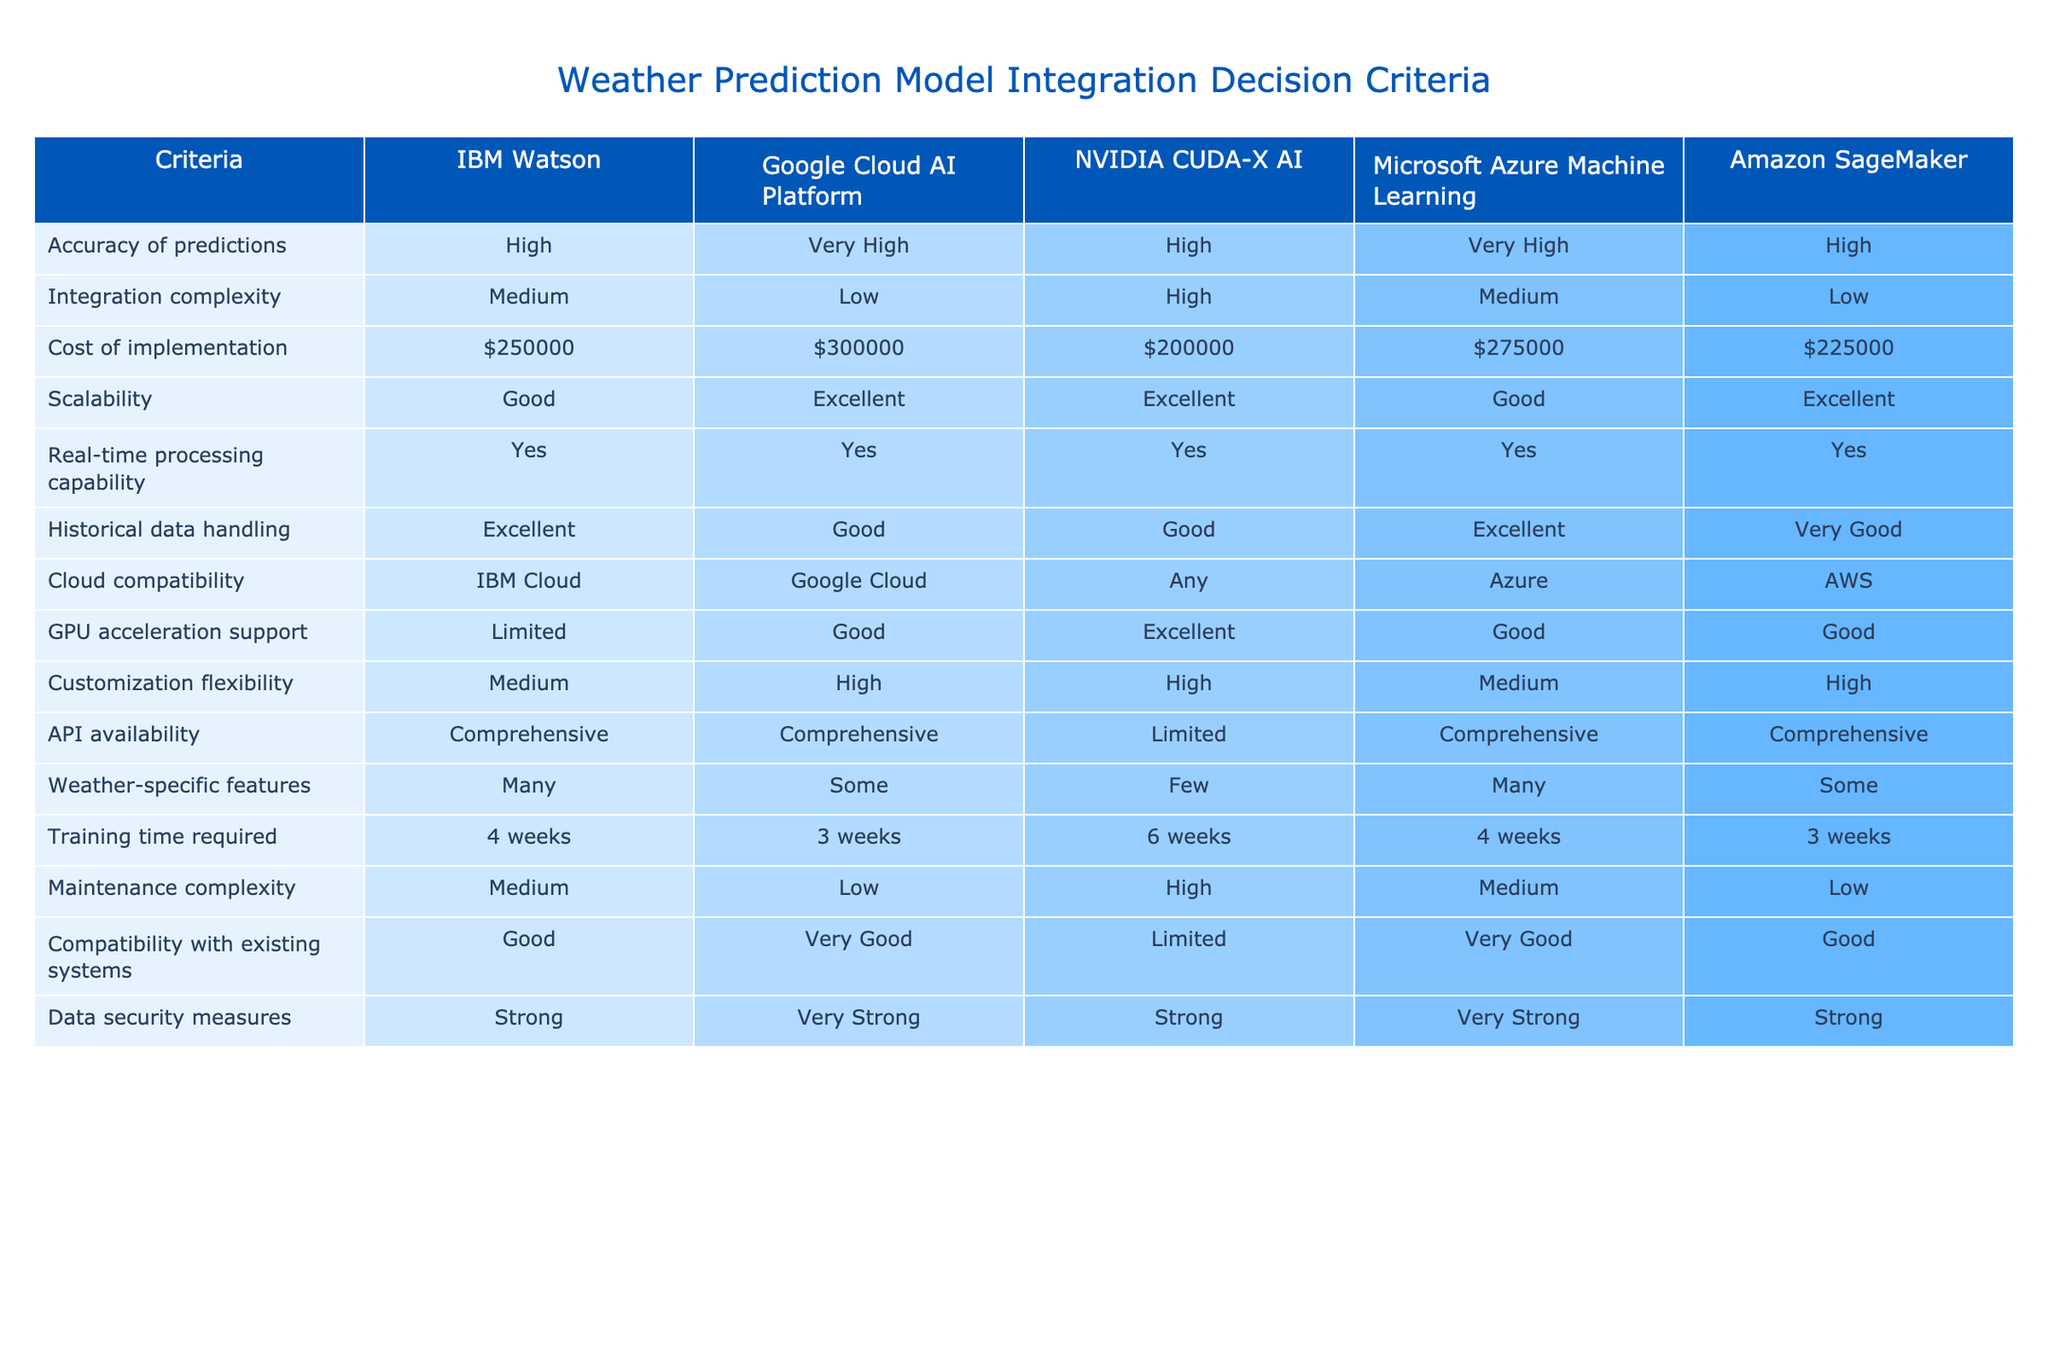What is the accuracy level of Google Cloud AI Platform? The table indicates that Google Cloud AI Platform has a "Very High" accuracy of predictions, which is directly stated in the row corresponding to that platform.
Answer: Very High Which integration option has the lowest cost of implementation? The table lists costs for each platform, and Amazon SageMaker ($225,000) has the lowest cost of implementation compared to the others.
Answer: Amazon SageMaker Is NVIDIA CUDA-X AI supported for API availability? According to the table, NVIDIA CUDA-X AI has "Limited" API availability, which means it does not support comprehensive API access like some other platforms.
Answer: No How many platforms have high scalability? By examining the scalability ratings, we find that three platforms (Amazon SageMaker, Google Cloud AI Platform, and NVIDIA CUDA-X AI) are rated "Excellent," indicating there are three platforms with high scalability.
Answer: Three Which platform requires the shortest training time? Looking at the training time column, both Google Cloud AI Platform and Amazon SageMaker require 3 weeks for training, which is the least among the options presented.
Answer: Google Cloud AI Platform and Amazon SageMaker What is the difference in cost of implementation between IBM Watson and Amazon SageMaker? IBM Watson costs $250,000, while Amazon SageMaker costs $225,000. The difference in cost is $250,000 - $225,000 = $25,000.
Answer: $25,000 Do both IBM Watson and Microsoft Azure Machine Learning allow for real-time processing? The table shows that both IBM Watson and Microsoft Azure Machine Learning have "Yes" for real-time processing capability, indicating that they both support this feature.
Answer: Yes Considering cloud compatibility, which platforms can be utilized with any cloud services? The table states that only NVIDIA CUDA-X AI has "Any" listed under cloud compatibility, meaning it can be used with any cloud services, while others are limited to specific clouds.
Answer: NVIDIA CUDA-X AI What platform has a strong level of data security measures? The table shows that IBM Watson, Microsoft Azure Machine Learning, and Amazon SageMaker all have "Strong" data security measures, but Google Cloud AI Platform has "Very Strong," so there are four platforms with strong or better measures.
Answer: Four platforms 